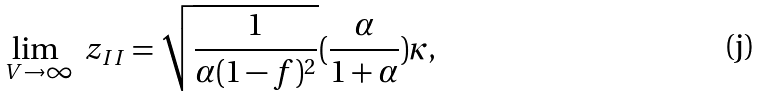Convert formula to latex. <formula><loc_0><loc_0><loc_500><loc_500>\lim _ { \ V \to \infty } \ z _ { I I } = \sqrt { \frac { 1 } { \alpha ( 1 - f ) ^ { 2 } } } ( \frac { \alpha } { 1 + \alpha } ) \kappa ,</formula> 